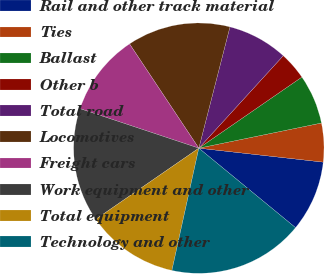Convert chart to OTSL. <chart><loc_0><loc_0><loc_500><loc_500><pie_chart><fcel>Rail and other track material<fcel>Ties<fcel>Ballast<fcel>Other b<fcel>Total road<fcel>Locomotives<fcel>Freight cars<fcel>Work equipment and other<fcel>Total equipment<fcel>Technology and other<nl><fcel>9.17%<fcel>5.0%<fcel>6.39%<fcel>3.61%<fcel>7.78%<fcel>13.33%<fcel>10.56%<fcel>14.72%<fcel>11.94%<fcel>17.5%<nl></chart> 